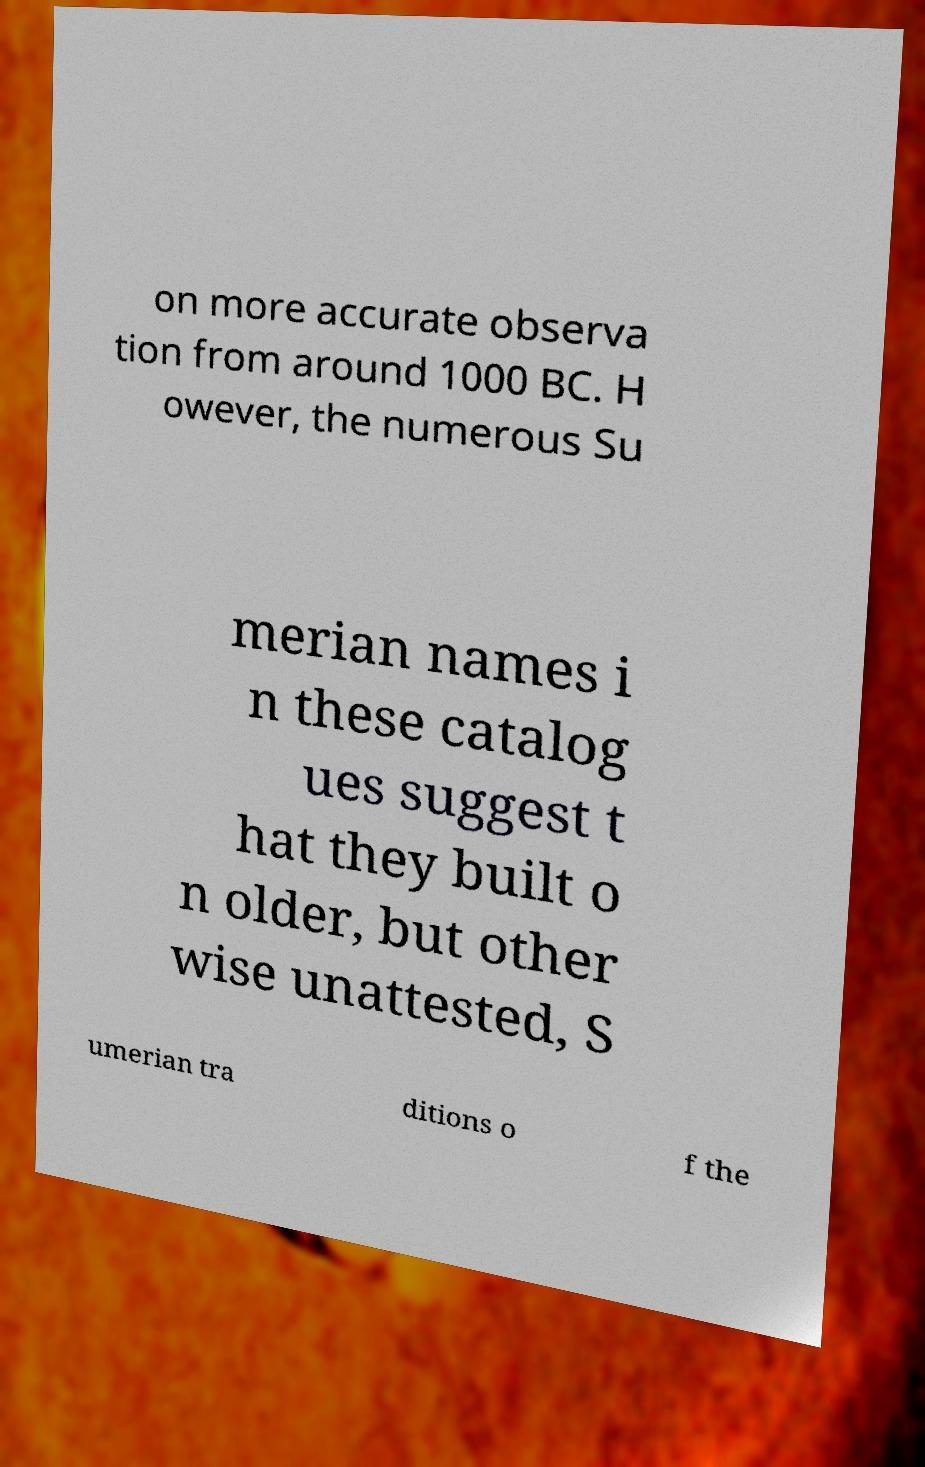Could you assist in decoding the text presented in this image and type it out clearly? on more accurate observa tion from around 1000 BC. H owever, the numerous Su merian names i n these catalog ues suggest t hat they built o n older, but other wise unattested, S umerian tra ditions o f the 